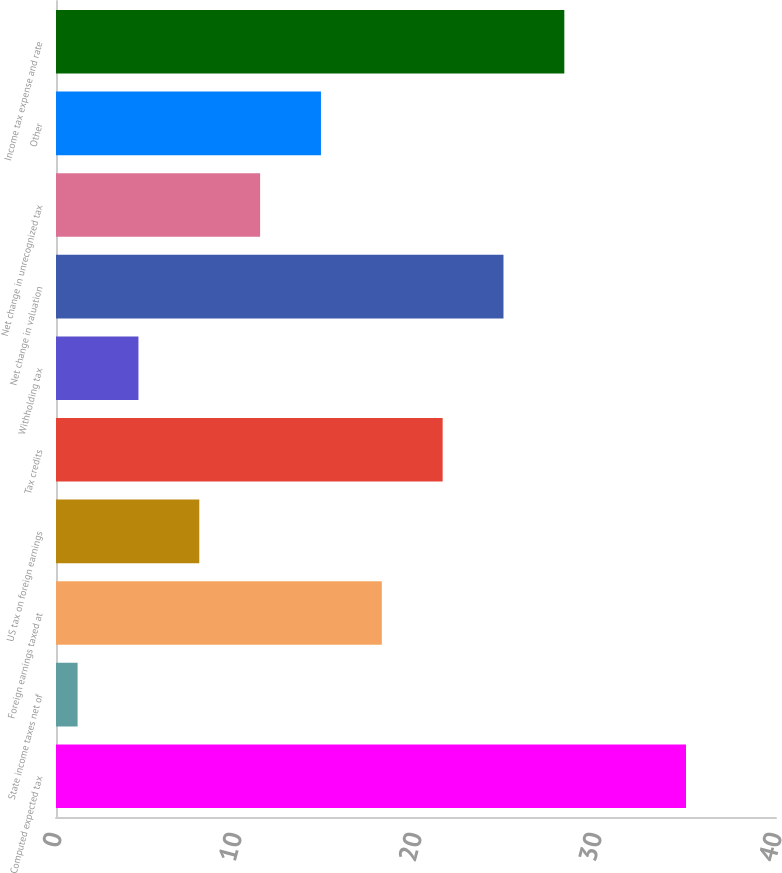Convert chart. <chart><loc_0><loc_0><loc_500><loc_500><bar_chart><fcel>Computed expected tax<fcel>State income taxes net of<fcel>Foreign earnings taxed at<fcel>US tax on foreign earnings<fcel>Tax credits<fcel>Withholding tax<fcel>Net change in valuation<fcel>Net change in unrecognized tax<fcel>Other<fcel>Income tax expense and rate<nl><fcel>35<fcel>1.2<fcel>18.1<fcel>7.96<fcel>21.48<fcel>4.58<fcel>24.86<fcel>11.34<fcel>14.72<fcel>28.24<nl></chart> 